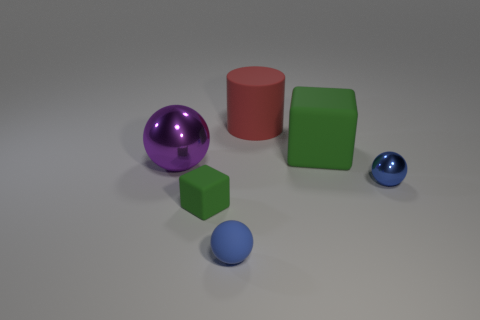Add 4 tiny things. How many objects exist? 10 Subtract all cylinders. How many objects are left? 5 Subtract all small matte balls. Subtract all blue metallic balls. How many objects are left? 4 Add 5 big green matte cubes. How many big green matte cubes are left? 6 Add 4 small blue matte things. How many small blue matte things exist? 5 Subtract 1 red cylinders. How many objects are left? 5 